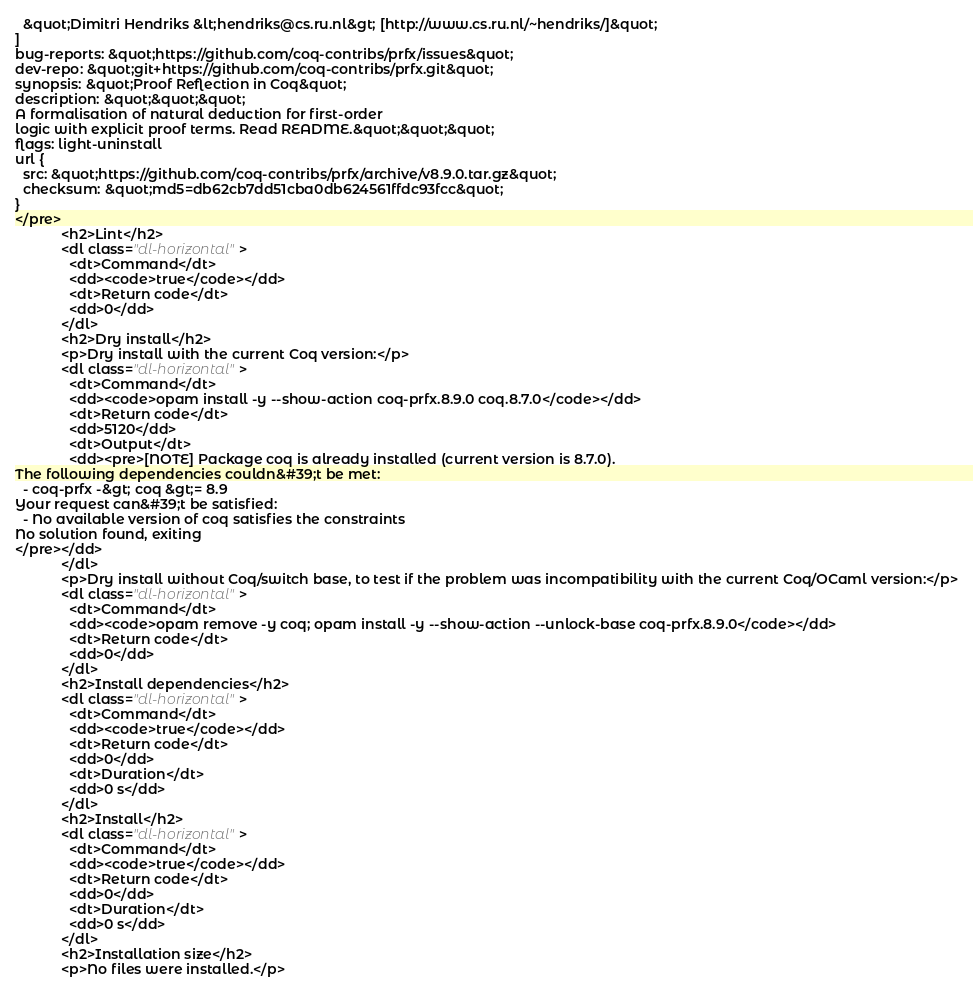<code> <loc_0><loc_0><loc_500><loc_500><_HTML_>  &quot;Dimitri Hendriks &lt;hendriks@cs.ru.nl&gt; [http://www.cs.ru.nl/~hendriks/]&quot;
]
bug-reports: &quot;https://github.com/coq-contribs/prfx/issues&quot;
dev-repo: &quot;git+https://github.com/coq-contribs/prfx.git&quot;
synopsis: &quot;Proof Reflection in Coq&quot;
description: &quot;&quot;&quot;
A formalisation of natural deduction for first-order
logic with explicit proof terms. Read README.&quot;&quot;&quot;
flags: light-uninstall
url {
  src: &quot;https://github.com/coq-contribs/prfx/archive/v8.9.0.tar.gz&quot;
  checksum: &quot;md5=db62cb7dd51cba0db624561ffdc93fcc&quot;
}
</pre>
            <h2>Lint</h2>
            <dl class="dl-horizontal">
              <dt>Command</dt>
              <dd><code>true</code></dd>
              <dt>Return code</dt>
              <dd>0</dd>
            </dl>
            <h2>Dry install</h2>
            <p>Dry install with the current Coq version:</p>
            <dl class="dl-horizontal">
              <dt>Command</dt>
              <dd><code>opam install -y --show-action coq-prfx.8.9.0 coq.8.7.0</code></dd>
              <dt>Return code</dt>
              <dd>5120</dd>
              <dt>Output</dt>
              <dd><pre>[NOTE] Package coq is already installed (current version is 8.7.0).
The following dependencies couldn&#39;t be met:
  - coq-prfx -&gt; coq &gt;= 8.9
Your request can&#39;t be satisfied:
  - No available version of coq satisfies the constraints
No solution found, exiting
</pre></dd>
            </dl>
            <p>Dry install without Coq/switch base, to test if the problem was incompatibility with the current Coq/OCaml version:</p>
            <dl class="dl-horizontal">
              <dt>Command</dt>
              <dd><code>opam remove -y coq; opam install -y --show-action --unlock-base coq-prfx.8.9.0</code></dd>
              <dt>Return code</dt>
              <dd>0</dd>
            </dl>
            <h2>Install dependencies</h2>
            <dl class="dl-horizontal">
              <dt>Command</dt>
              <dd><code>true</code></dd>
              <dt>Return code</dt>
              <dd>0</dd>
              <dt>Duration</dt>
              <dd>0 s</dd>
            </dl>
            <h2>Install</h2>
            <dl class="dl-horizontal">
              <dt>Command</dt>
              <dd><code>true</code></dd>
              <dt>Return code</dt>
              <dd>0</dd>
              <dt>Duration</dt>
              <dd>0 s</dd>
            </dl>
            <h2>Installation size</h2>
            <p>No files were installed.</p></code> 